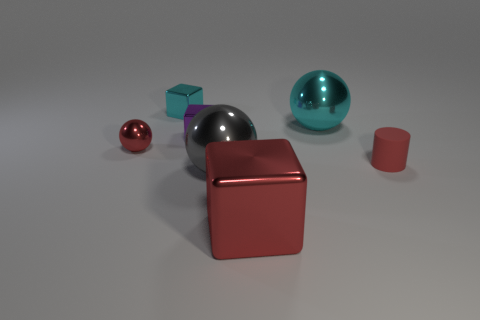Add 3 small metallic things. How many objects exist? 10 Subtract all tiny purple metal blocks. How many blocks are left? 2 Subtract all red blocks. How many blocks are left? 2 Subtract 1 cubes. How many cubes are left? 2 Subtract all red cubes. Subtract all large objects. How many objects are left? 3 Add 5 big red objects. How many big red objects are left? 6 Add 7 large red things. How many large red things exist? 8 Subtract 1 red cylinders. How many objects are left? 6 Subtract all balls. How many objects are left? 4 Subtract all purple balls. Subtract all red cylinders. How many balls are left? 3 